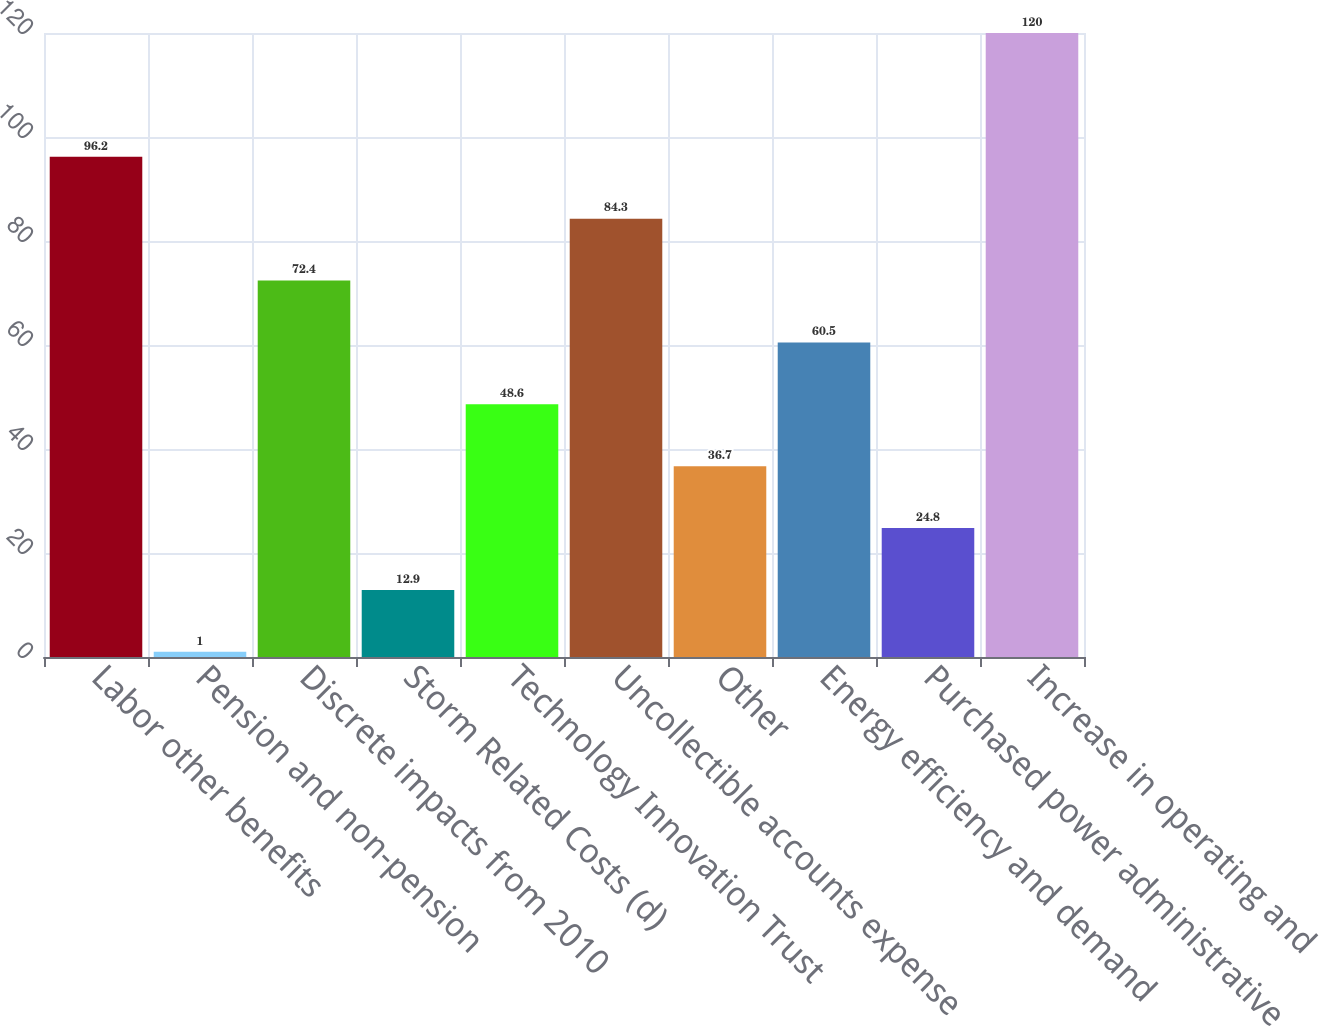Convert chart. <chart><loc_0><loc_0><loc_500><loc_500><bar_chart><fcel>Labor other benefits<fcel>Pension and non-pension<fcel>Discrete impacts from 2010<fcel>Storm Related Costs (d)<fcel>Technology Innovation Trust<fcel>Uncollectible accounts expense<fcel>Other<fcel>Energy efficiency and demand<fcel>Purchased power administrative<fcel>Increase in operating and<nl><fcel>96.2<fcel>1<fcel>72.4<fcel>12.9<fcel>48.6<fcel>84.3<fcel>36.7<fcel>60.5<fcel>24.8<fcel>120<nl></chart> 